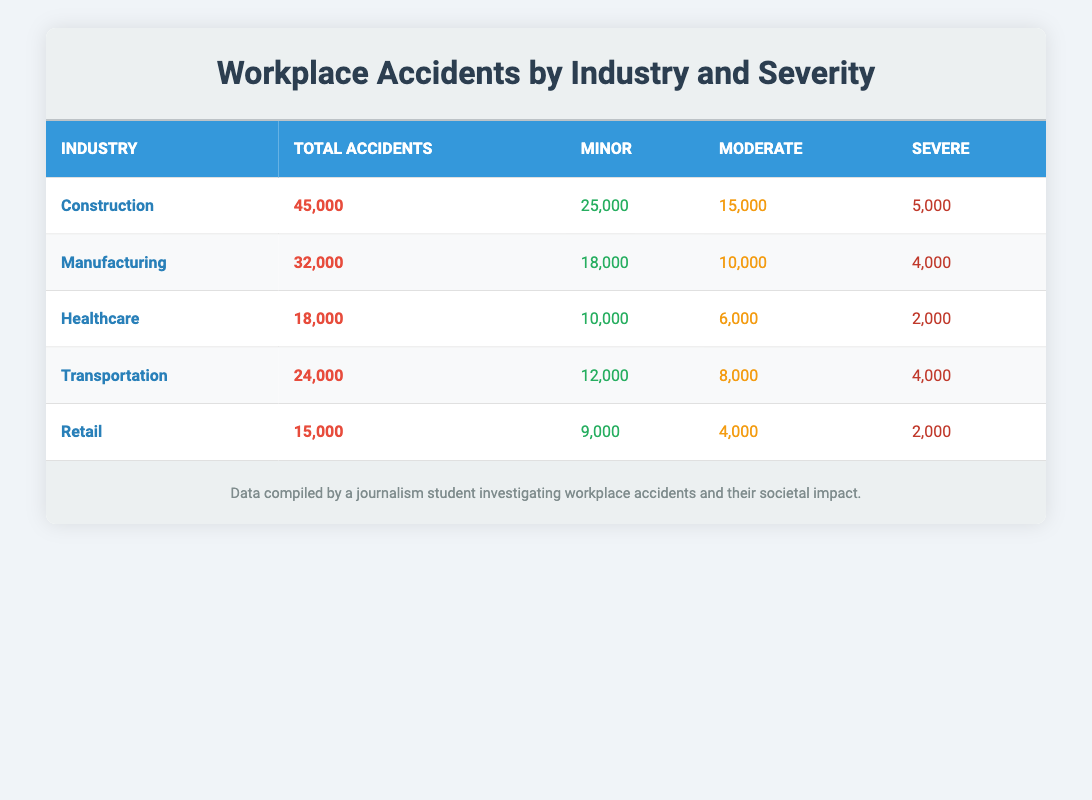What is the total number of workplace accidents in the Construction industry? According to the table, the total number of workplace accidents listed under the Construction industry is specifically mentioned in the row corresponding to this industry, which shows a total of 45,000 accidents.
Answer: 45,000 Which industry has the highest number of severe accidents? By comparing the total number of severe accidents across all industries, we see that the Construction industry has 5,000 severe accidents, while Manufacturing has 4,000, Healthcare has 2,000, Transportation has 4,000, and Retail has 2,000. The highest number among these is still 5,000 in the Construction industry.
Answer: Construction How many more minor accidents occurred in the Manufacturing industry compared to the Healthcare industry? The Manufacturing industry reports 18,000 minor accidents, while the Healthcare industry reports 10,000 minor accidents. The difference in the number of minor accidents is calculated by subtracting 10,000 from 18,000, giving us 8,000 more accidents in Manufacturing compared to Healthcare.
Answer: 8,000 Is it true that the Transportation industry has more moderate accidents than the Retail industry? Looking at the table, the Transportation industry has 8,000 moderate accidents, while the Retail industry has only 4,000 moderate accidents. Since 8,000 is greater than 4,000, the statement is true.
Answer: Yes What is the average number of total accidents across all listed industries? To find the average, we first sum the total accidents in each industry: Construction (45,000) + Manufacturing (32,000) + Healthcare (18,000) + Transportation (24,000) + Retail (15,000) equals 134,000. Since there are 5 industries, we divide 134,000 by 5 to find the average, which is 26,800 accidents.
Answer: 26,800 How many severe accidents are reported in the Retail industry? From the table, we see that the Retail industry reports 2,000 severe accidents listed under that column for the Retail row.
Answer: 2,000 Which industry has the lowest total number of accidents? From the total accident counts in the table, we check each industry and find that the Healthcare industry has the lowest total with 18,000 reported accidents, compared to others such as Construction (45,000), Manufacturing (32,000), Transportation (24,000), and Retail (15,000).
Answer: Healthcare How many total accidents occurred in the Manufacturing and Retail industries combined? To find the combined total of accidents in both the Manufacturing and Retail industries, we add the totals: 32,000 (Manufacturing) + 15,000 (Retail) = 47,000 total accidents in these two industries.
Answer: 47,000 